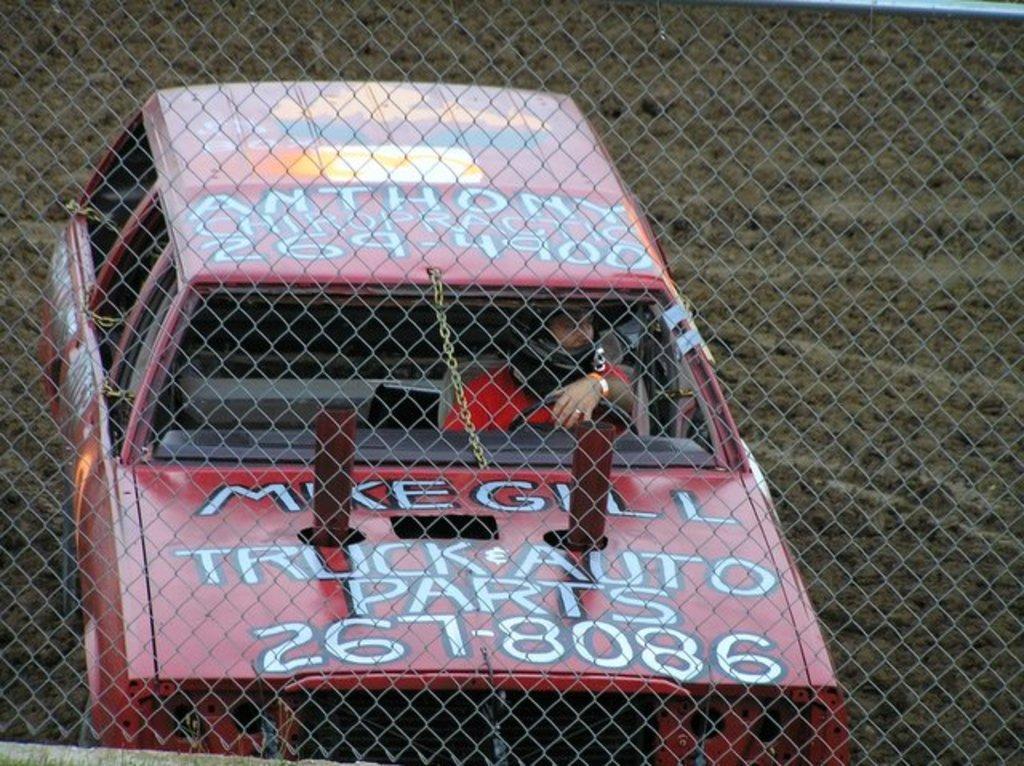Please provide a concise description of this image. In this image we can see a person driving a car. In the foreground of the image there is grill. 